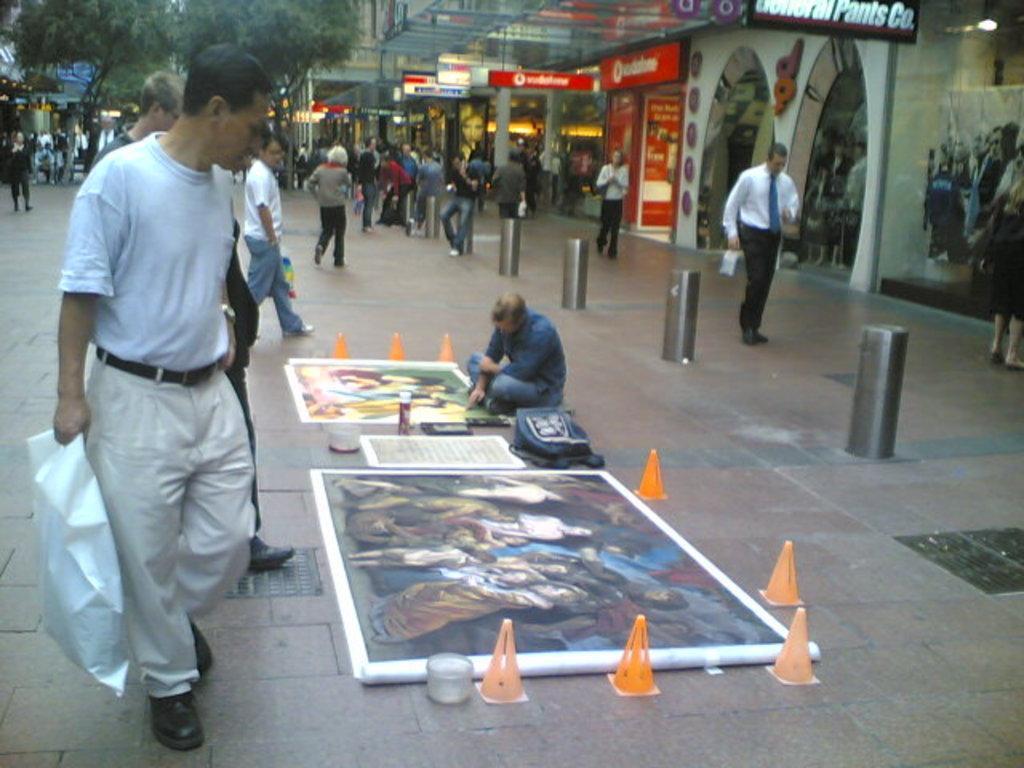Can you describe this image briefly? In this image, I can see groups of people walking. I can see a person sitting, a bag, and posters on the floor. On the right side of the image, I can see the shops with name boards and lights. At the top left side of the image, there are trees. 